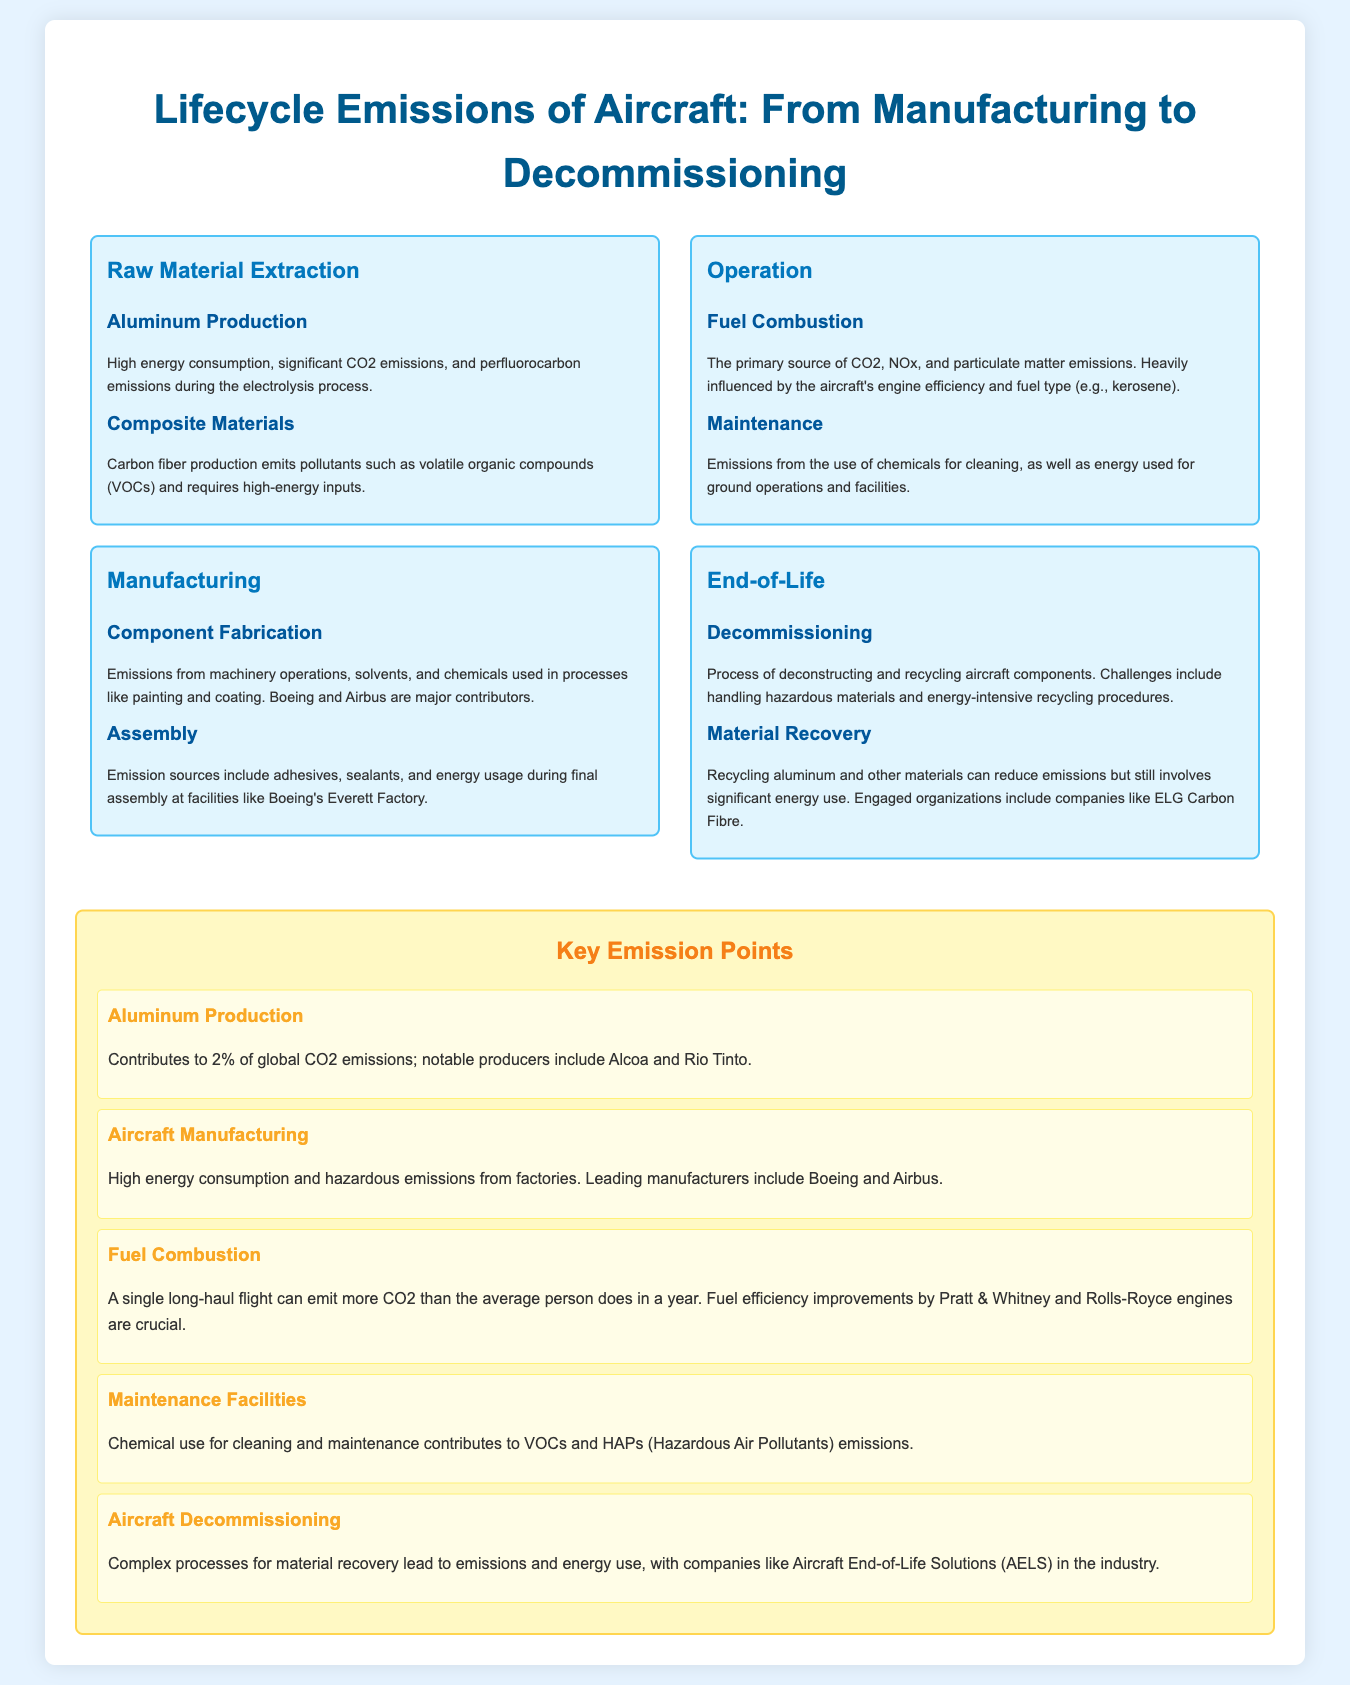What are the two major emission sources during raw material extraction? The document identifies aluminum production and composite materials as the two major emission sources during raw material extraction.
Answer: Aluminum production and composite materials Which company is noted for significant emissions during component fabrication? The document mentions Boeing and Airbus as major contributors to emissions during component fabrication.
Answer: Boeing and Airbus What type of emissions is primarily produced by fuel combustion? The document states that fuel combustion is the primary source of CO2, NOx, and particulate matter emissions.
Answer: CO2, NOx, and particulate matter Which two processes contribute to emissions at the end-of-life phase of aircraft? The document highlights decommissioning and material recovery as the two processes that contribute to emissions at the end-of-life phase.
Answer: Decommissioning and material recovery What percentage of global CO2 emissions is attributed to aluminum production? The document states that aluminum production contributes to 2% of global CO2 emissions.
Answer: 2% Which engine manufacturers are crucial for fuel efficiency improvements? The document refers to Pratt & Whitney and Rolls-Royce as the companies crucial for fuel efficiency improvements.
Answer: Pratt & Whitney and Rolls-Royce What type of compounds are emitted from maintenance facilities due to chemical use? The document mentions that cleaning and maintenance in facilities contribute to VOCs and HAPs emissions.
Answer: VOCs and HAPs What is a challenge faced during aircraft decommissioning? The document notes that handling hazardous materials presents a challenge during the decommissioning process.
Answer: Handling hazardous materials What kind of energy demands are associated with composite material production? The document explains that carbon fiber production requires high-energy inputs.
Answer: High-energy inputs 